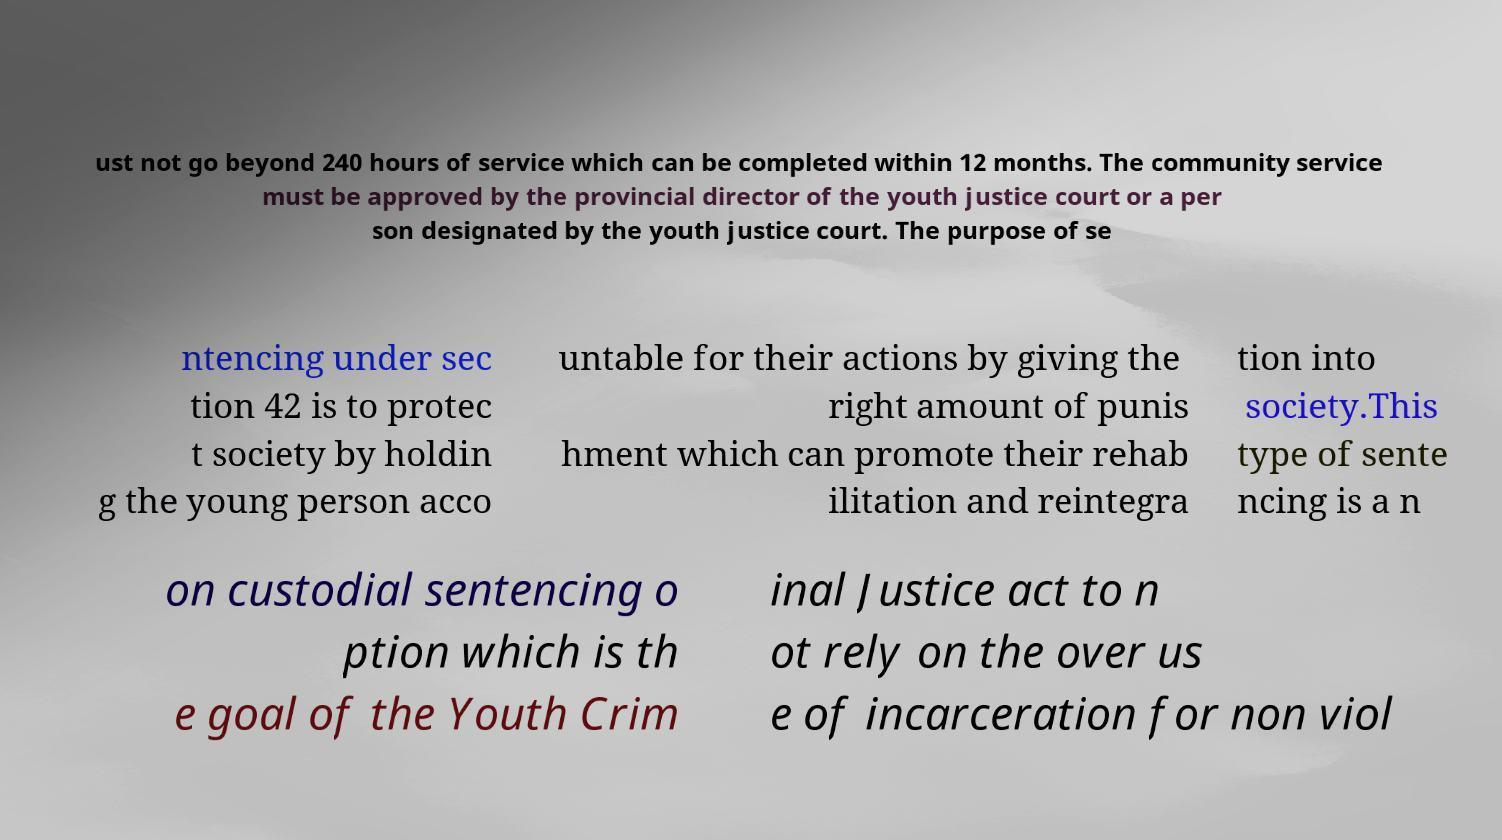Could you extract and type out the text from this image? ust not go beyond 240 hours of service which can be completed within 12 months. The community service must be approved by the provincial director of the youth justice court or a per son designated by the youth justice court. The purpose of se ntencing under sec tion 42 is to protec t society by holdin g the young person acco untable for their actions by giving the right amount of punis hment which can promote their rehab ilitation and reintegra tion into society.This type of sente ncing is a n on custodial sentencing o ption which is th e goal of the Youth Crim inal Justice act to n ot rely on the over us e of incarceration for non viol 